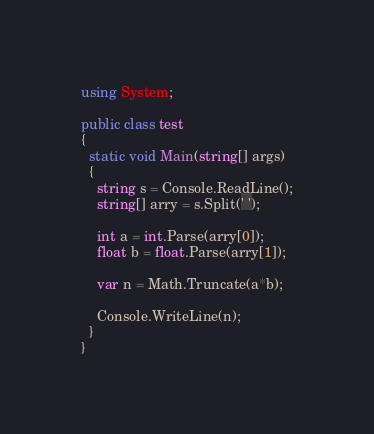<code> <loc_0><loc_0><loc_500><loc_500><_C#_>using System;

public class test
{
  static void Main(string[] args)
  {
    string s = Console.ReadLine();
    string[] arry = s.Split(' ');

    int a = int.Parse(arry[0]);
    float b = float.Parse(arry[1]);

    var n = Math.Truncate(a*b);

    Console.WriteLine(n);
  }
}</code> 